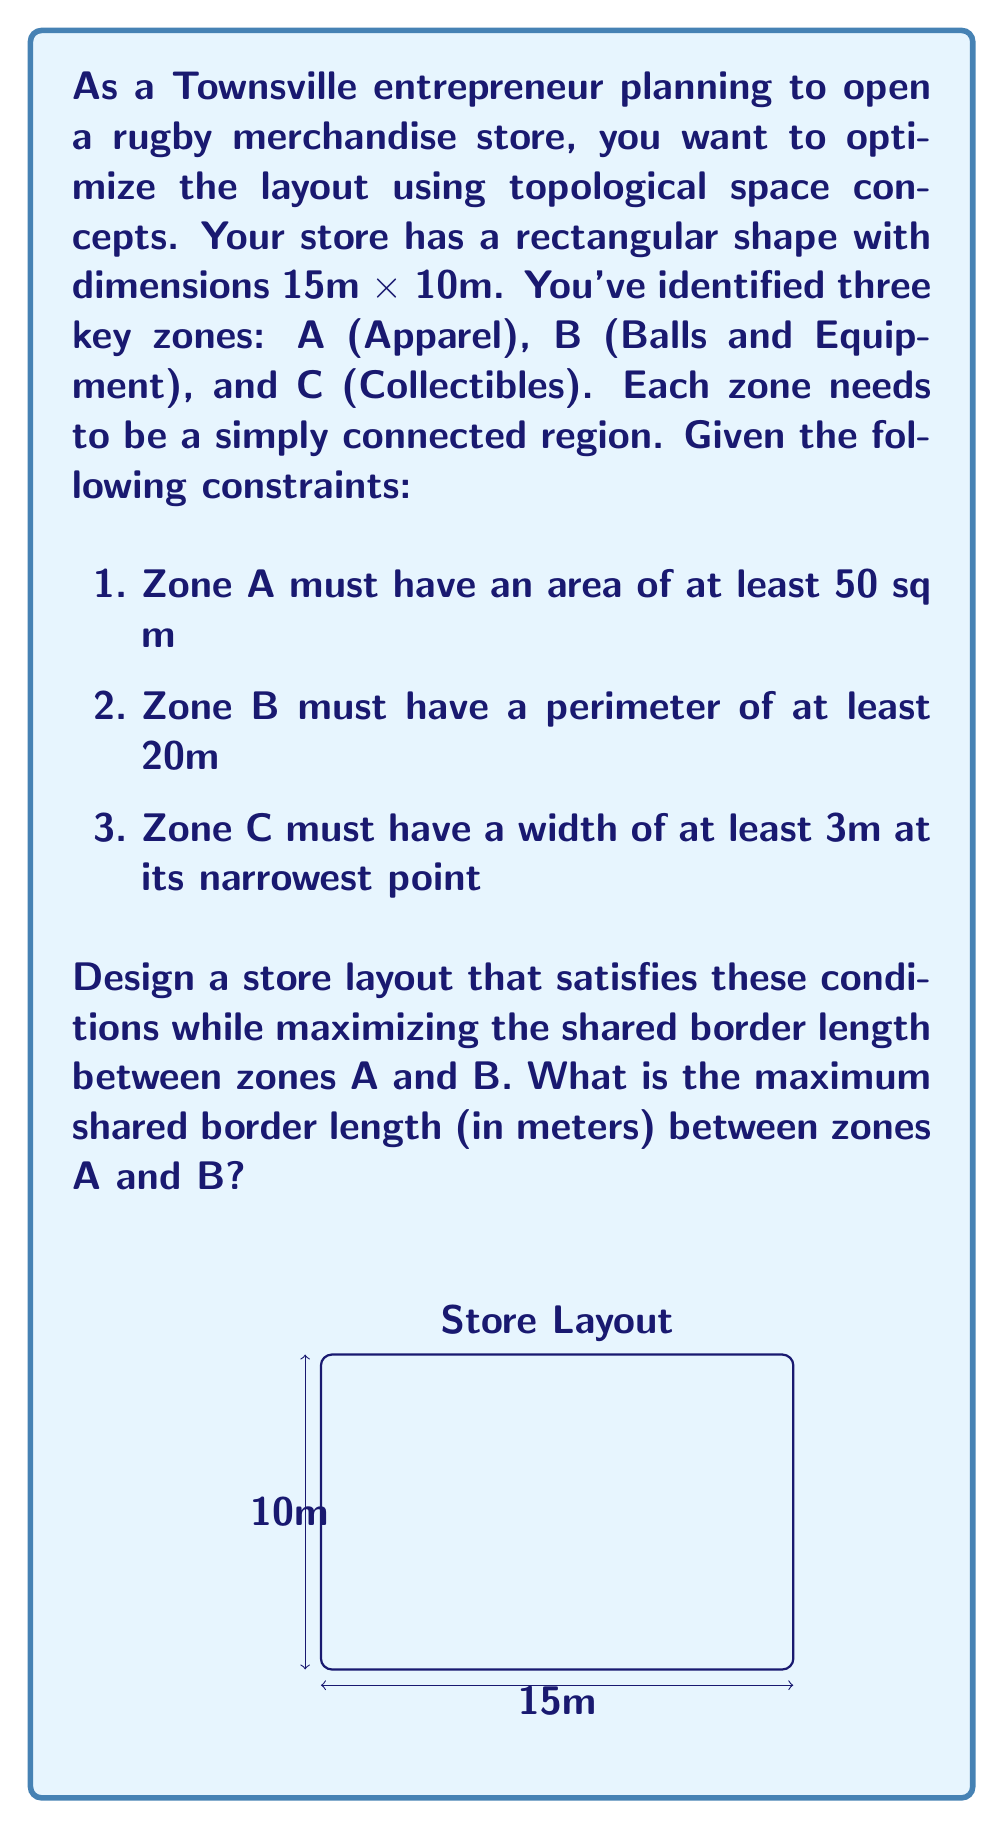Teach me how to tackle this problem. Let's approach this problem step-by-step using topological concepts:

1) First, we need to satisfy the area constraint for Zone A:
   Area of Zone A ≥ 50 sq m

2) For Zone B, we need to ensure a perimeter of at least 20m. The most efficient shape for this is a rectangle.

3) Zone C must have a minimum width of 3m at its narrowest point.

4) To maximize the shared border between A and B, we should make this border as long as possible while satisfying all constraints.

5) The optimal layout will likely have Zone C along one of the short sides of the store, as this allows for the longest possible border between A and B.

6) Let's place Zone C on the right side of the store:
   
   [asy]
   unitsize(10);
   draw((0,0)--(15,0)--(15,10)--(0,10)--cycle);
   draw((12,0)--(12,10));
   label("C", (13.5,5));
   label("A", (6,7));
   label("B", (6,3));
   [/asy]

7) This leaves a 12m x 10m area for zones A and B.

8) To maximize the shared border, we should divide this area with a horizontal line:
   
   [asy]
   unitsize(10);
   draw((0,0)--(15,0)--(15,10)--(0,10)--cycle);
   draw((12,0)--(12,10));
   draw((0,5)--(12,5));
   label("C", (13.5,5));
   label("A", (6,7.5));
   label("B", (6,2.5));
   [/asy]

9) This gives us:
   Zone A: 12m x 5m = 60 sq m (satisfies constraint 1)
   Zone B: 12m x 5m, perimeter = 34m (satisfies constraint 2)
   Zone C: 3m x 10m (satisfies constraint 3)

10) The shared border between A and B is the full width of the remaining space: 12m.

Therefore, the maximum shared border length between zones A and B is 12 meters.
Answer: 12 meters 